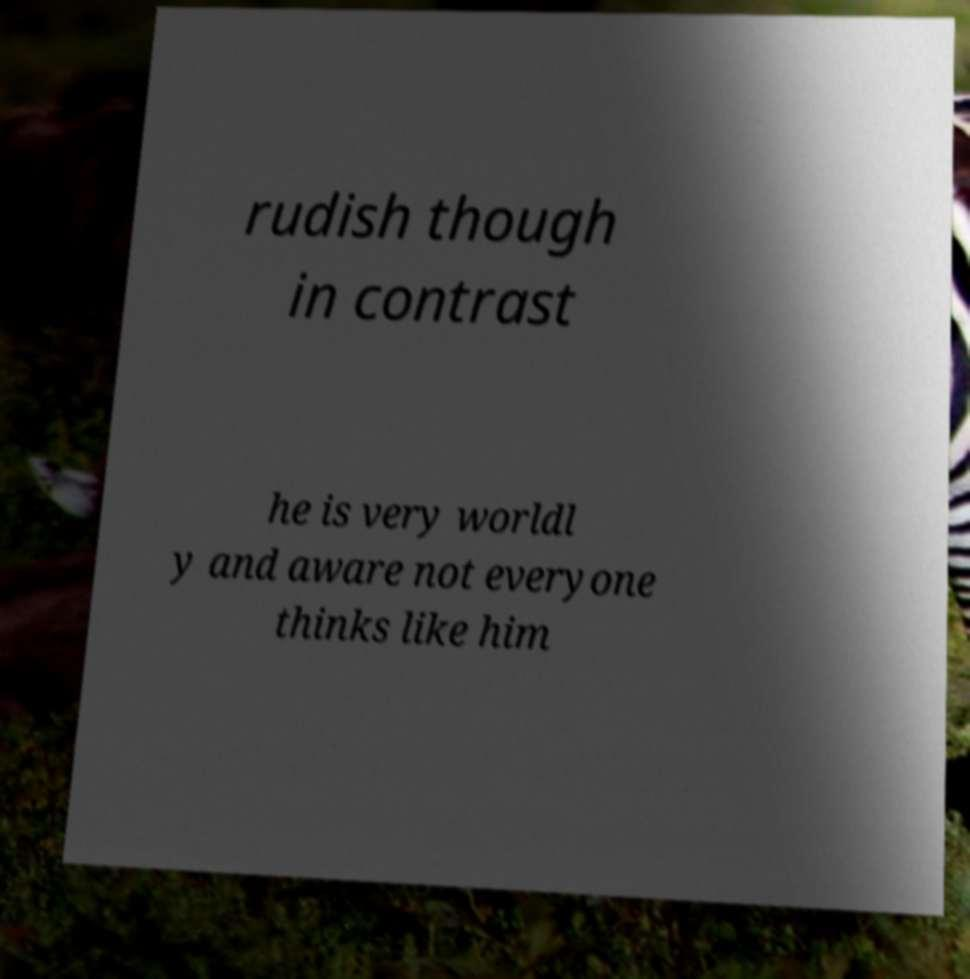Can you accurately transcribe the text from the provided image for me? rudish though in contrast he is very worldl y and aware not everyone thinks like him 